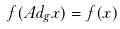<formula> <loc_0><loc_0><loc_500><loc_500>f ( A d _ { g } x ) = f ( x )</formula> 